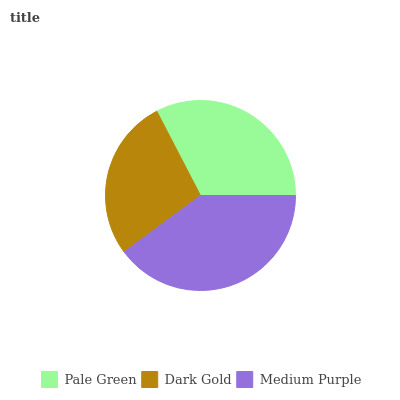Is Dark Gold the minimum?
Answer yes or no. Yes. Is Medium Purple the maximum?
Answer yes or no. Yes. Is Medium Purple the minimum?
Answer yes or no. No. Is Dark Gold the maximum?
Answer yes or no. No. Is Medium Purple greater than Dark Gold?
Answer yes or no. Yes. Is Dark Gold less than Medium Purple?
Answer yes or no. Yes. Is Dark Gold greater than Medium Purple?
Answer yes or no. No. Is Medium Purple less than Dark Gold?
Answer yes or no. No. Is Pale Green the high median?
Answer yes or no. Yes. Is Pale Green the low median?
Answer yes or no. Yes. Is Medium Purple the high median?
Answer yes or no. No. Is Dark Gold the low median?
Answer yes or no. No. 